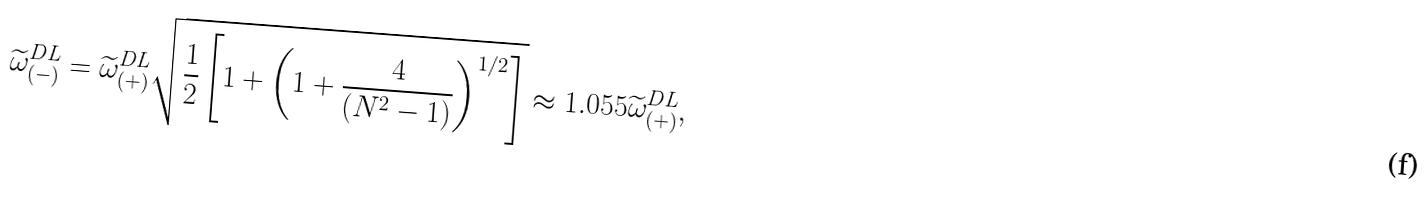Convert formula to latex. <formula><loc_0><loc_0><loc_500><loc_500>\widetilde { \omega } ^ { D L } _ { ( - ) } = \widetilde { \omega } ^ { D L } _ { ( + ) } \sqrt { \frac { 1 } { 2 } \left [ 1 + \left ( 1 + \frac { 4 } { ( N ^ { 2 } - 1 ) } \right ) ^ { 1 / 2 } \right ] } \approx 1 . 0 5 5 \widetilde { \omega } ^ { D L } _ { ( + ) } ,</formula> 